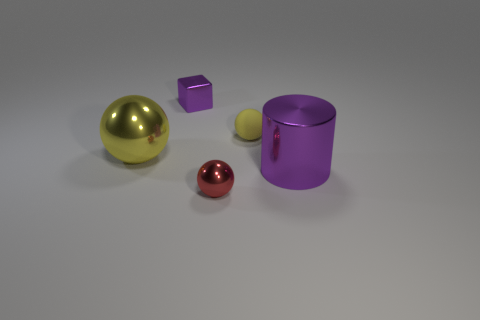Add 4 big yellow shiny cubes. How many objects exist? 9 Subtract all cylinders. How many objects are left? 4 Subtract 0 yellow cubes. How many objects are left? 5 Subtract all big purple metal things. Subtract all big purple shiny cylinders. How many objects are left? 3 Add 3 yellow spheres. How many yellow spheres are left? 5 Add 5 tiny cyan metallic objects. How many tiny cyan metallic objects exist? 5 